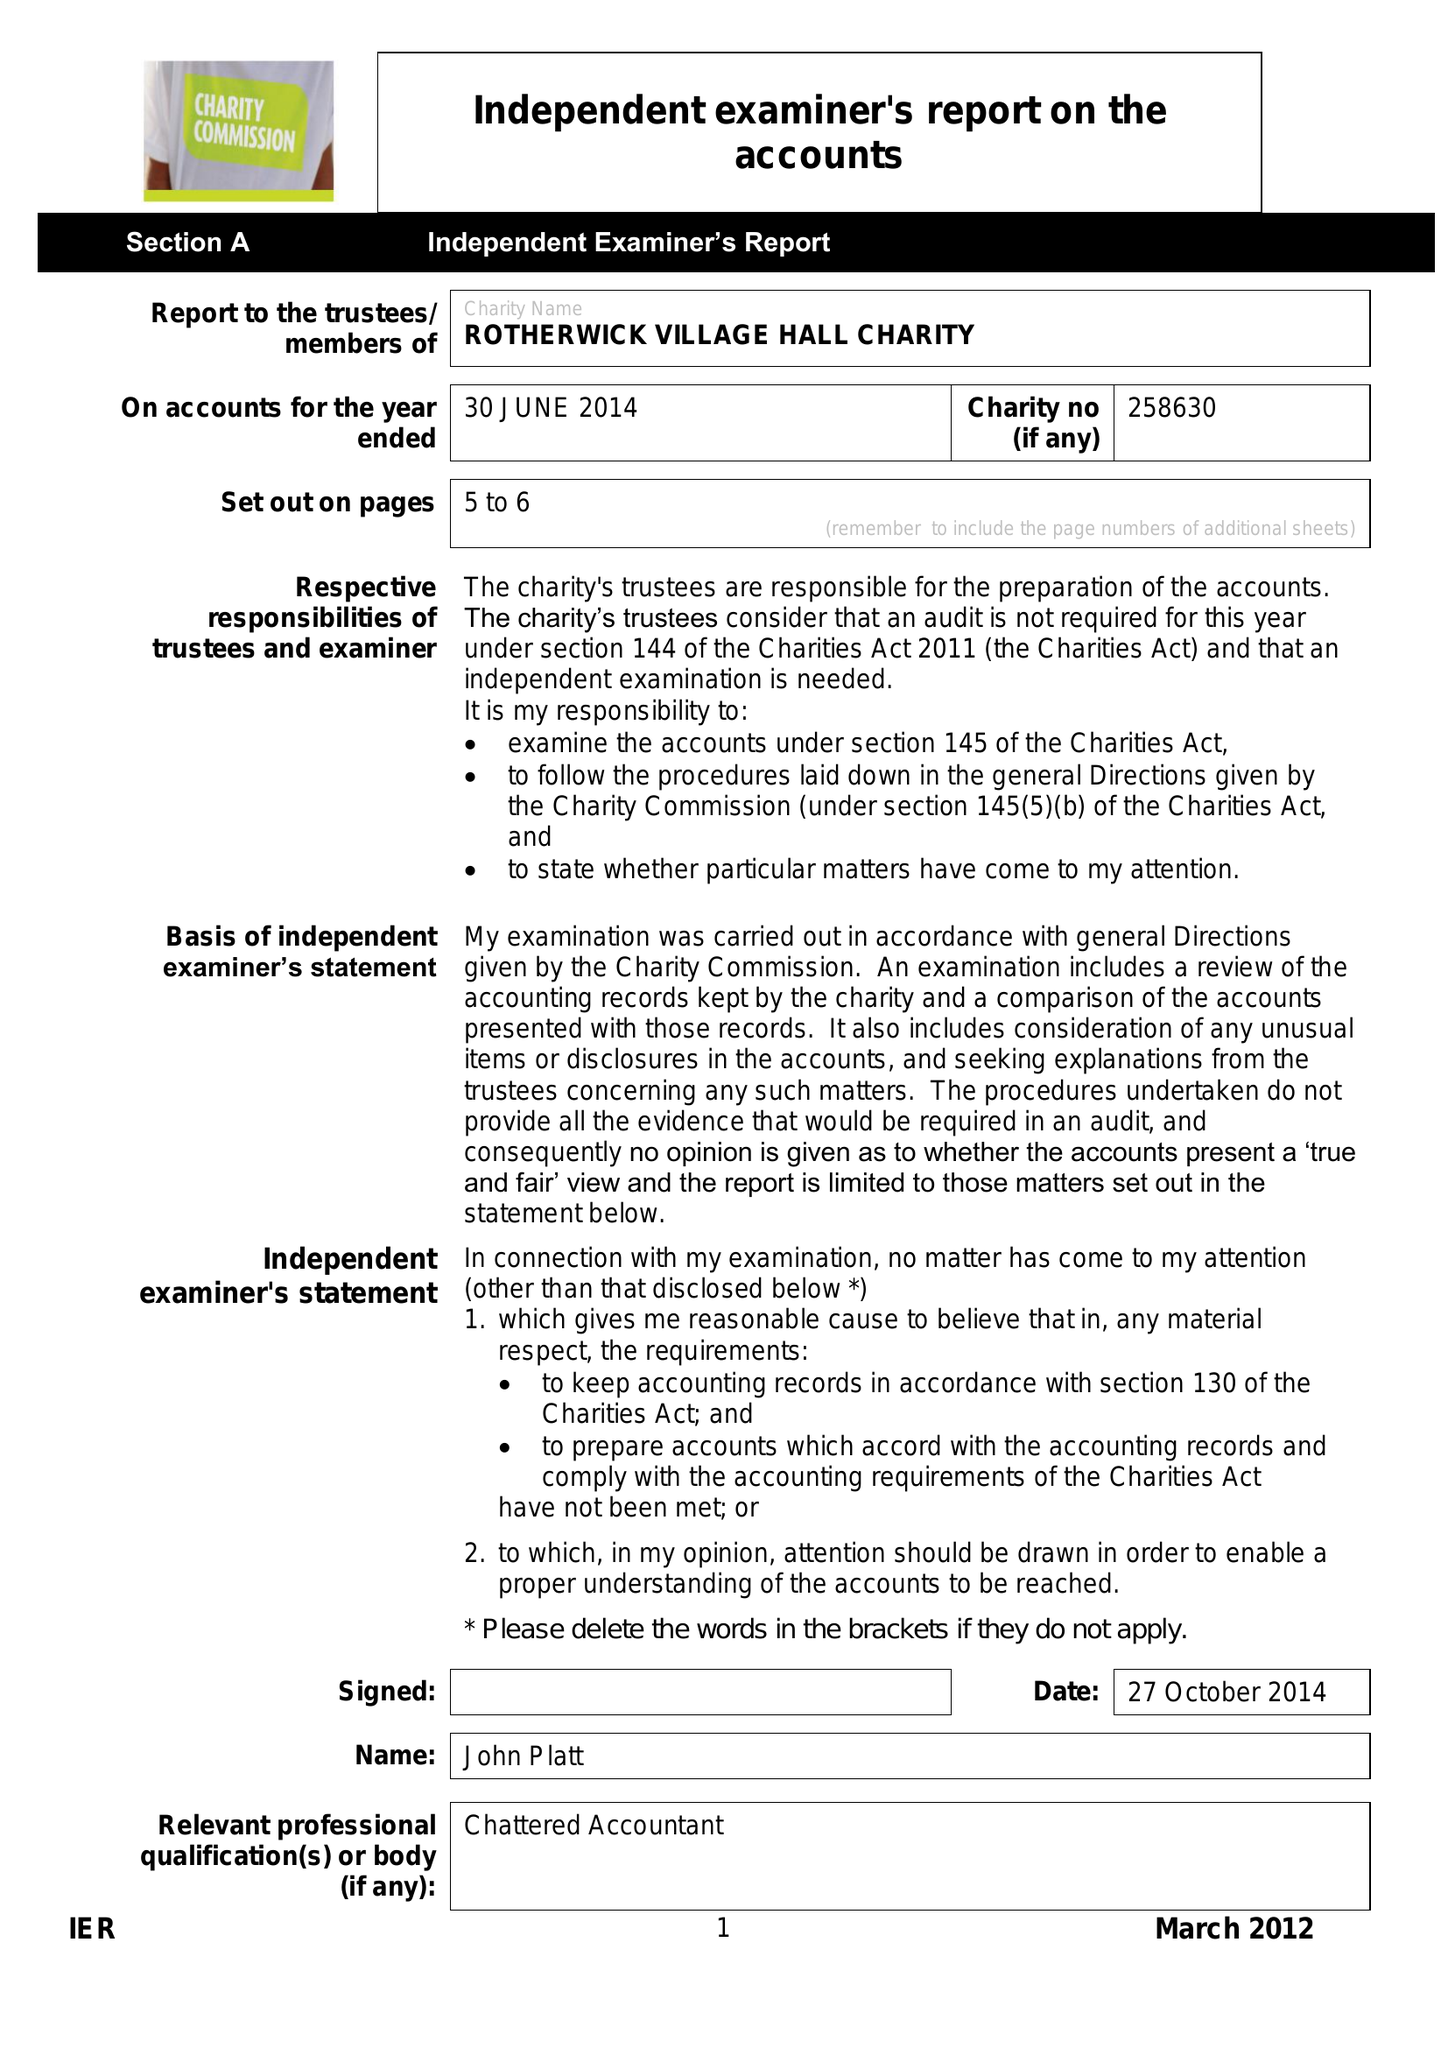What is the value for the report_date?
Answer the question using a single word or phrase. 2014-06-30 